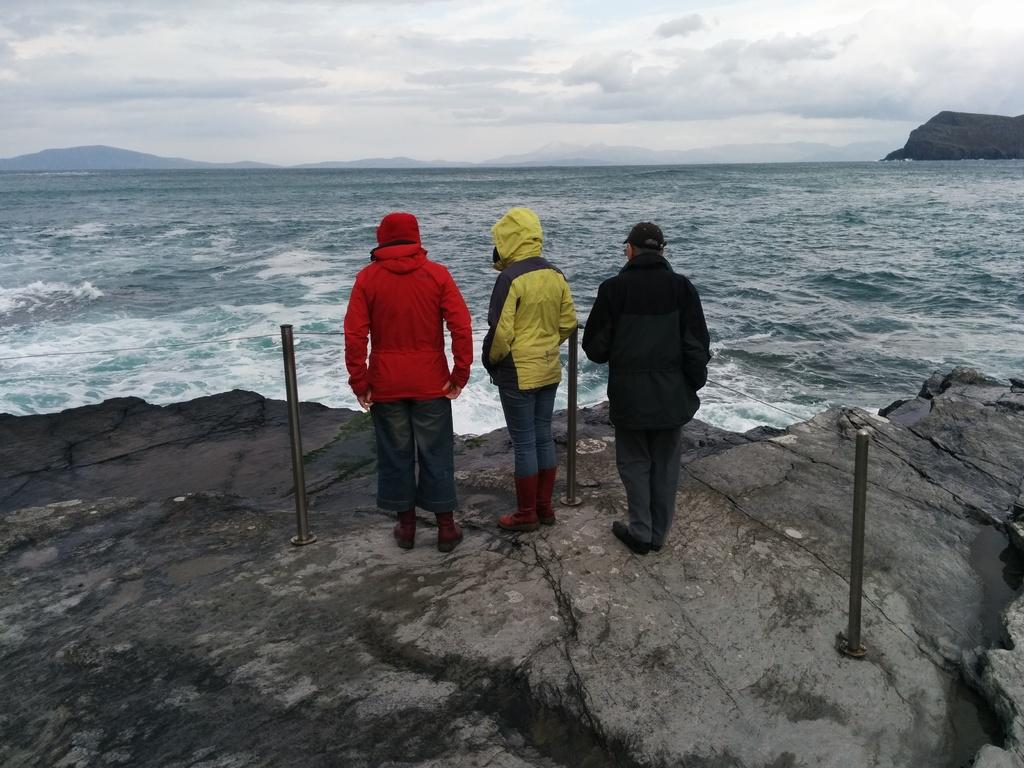How many people are in the front of the image? There are three people standing in the front of the image. What is visible in the background of the image? Water and the sky are visible in the background of the image. What can be seen in the sky? Clouds are present in the sky. How many balls are being juggled by the people in the image? There are no balls visible in the image, and the people are not shown juggling anything. What grade is the tramp in the image? There is no tramp present in the image, so it is not possible to determine its grade. 